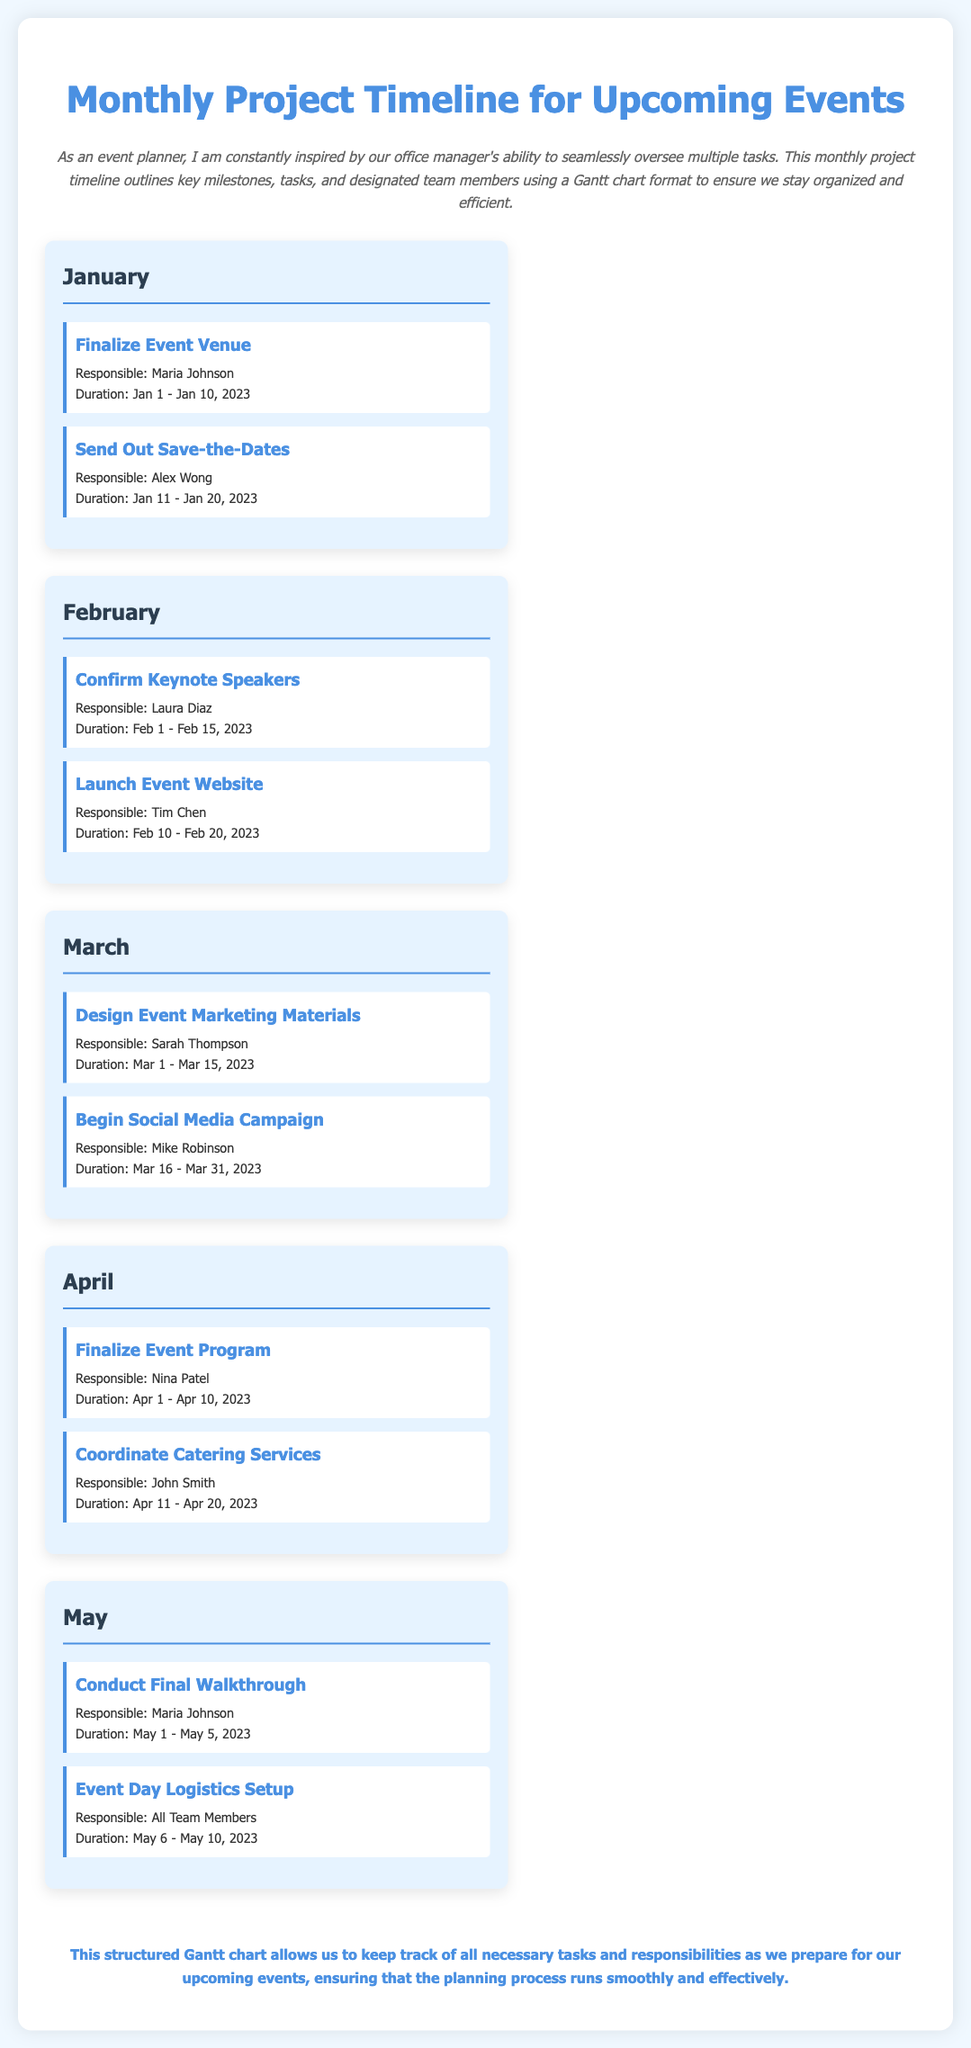what is the duration for finalizing the event venue? The duration for finalizing the event venue is specified in the document as Jan 1 - Jan 10, 2023.
Answer: Jan 1 - Jan 10, 2023 who is responsible for sending out save-the-dates? According to the document, Alex Wong is responsible for sending out save-the-dates.
Answer: Alex Wong what is the main task in March? The main tasks in March are designing event marketing materials and beginning the social media campaign, both outlined in the document.
Answer: Design Event Marketing Materials, Begin Social Media Campaign when should the final walkthrough be conducted? The document states that the final walkthrough should be conducted from May 1 to May 5, 2023.
Answer: May 1 - May 5, 2023 which month includes coordinating catering services? April is the month in which coordinating catering services is scheduled, as indicated in the document.
Answer: April who is responsible for the event day logistics setup? The document mentions that all team members are responsible for the event day logistics setup.
Answer: All Team Members what is the purpose of the timeline in the document? The timeline aims to keep track of all necessary tasks and responsibilities as preparations are made for upcoming events.
Answer: To keep track of tasks and responsibilities what color is used for the headings in the milestones? The headings in the milestones use a blue color for visibility in the document design.
Answer: Blue 